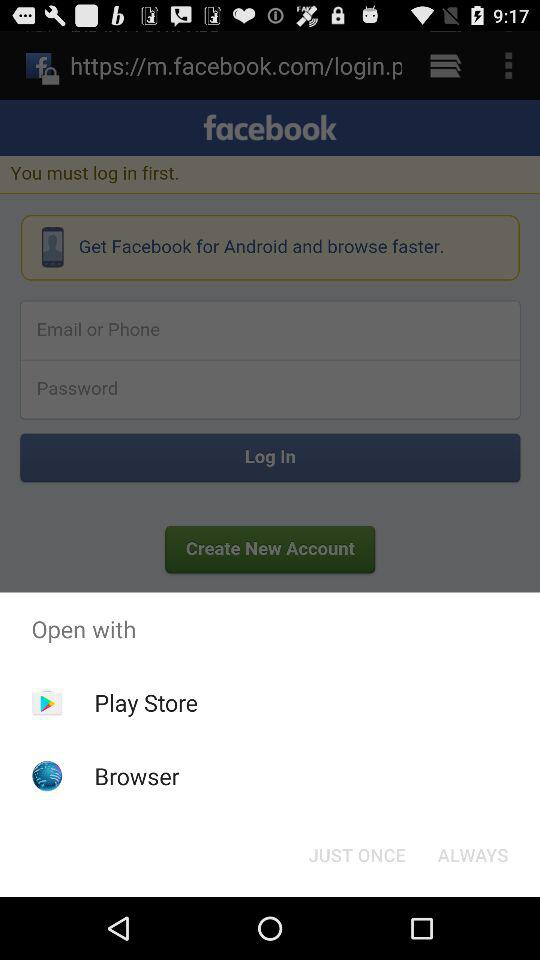What application is used for log in? You can log in with "facebook". 